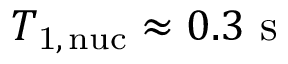Convert formula to latex. <formula><loc_0><loc_0><loc_500><loc_500>T _ { 1 , \, n u c } \approx 0 . 3 s</formula> 